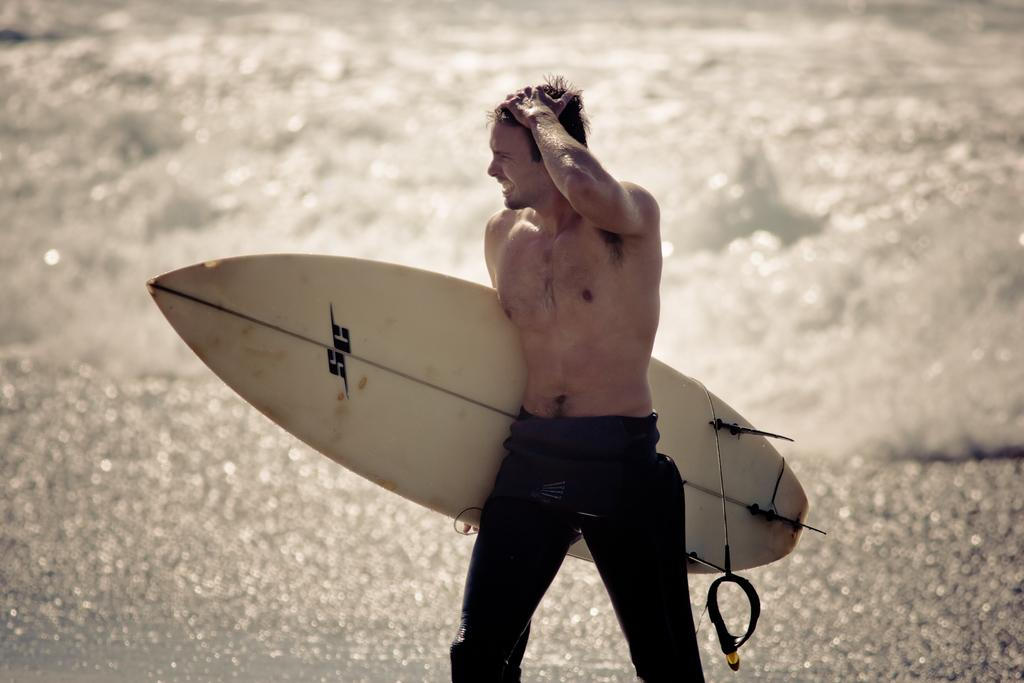What is happening in the image? There is a person in the image, and they are walking on the road. What is the person holding in the image? The person is holding a surfboard. What type of grass is growing on the person's head in the image? There is no grass growing on the person's head in the image. What emotion is the person displaying while holding the quince in the image? There is no quince present in the image, and the person's emotions cannot be determined from the image alone. 